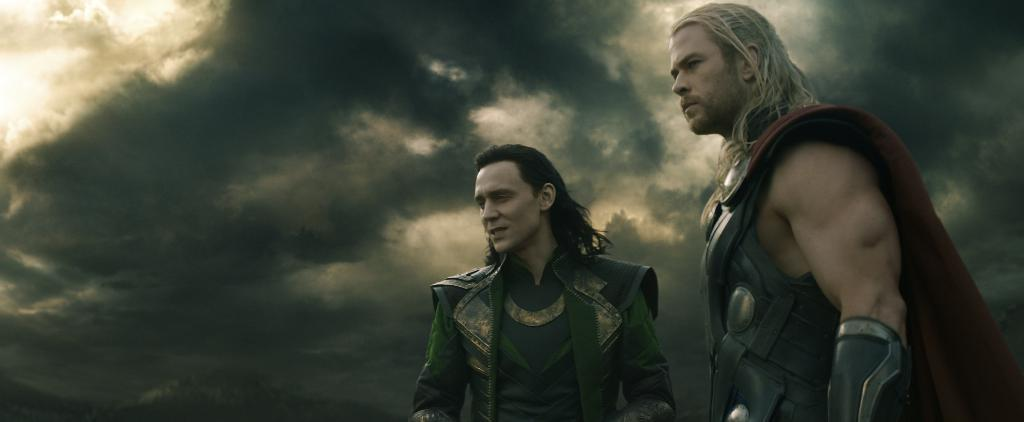How many people are in the image? There are two persons in the image. What are the persons wearing? The persons are wearing fancy dresses. What can be seen in the background of the image? The sky is visible in the background of the image. What type of list can be seen in the image? There is no list present in the image. What kind of creature is crawling on the persons' dresses in the image? There are no creatures visible on the persons' dresses in the image. 